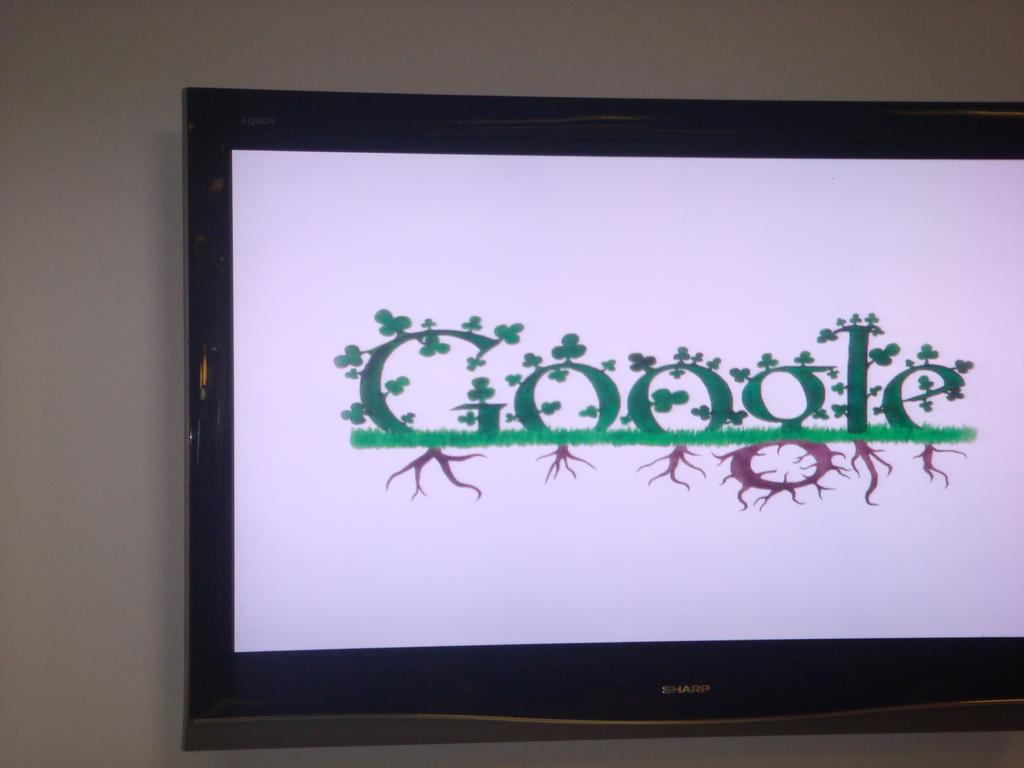<image>
Create a compact narrative representing the image presented. The screen on the tv shows fancy lettering for Google so that each letter looks like clovers are growing out of it and roots are growing below the word. 